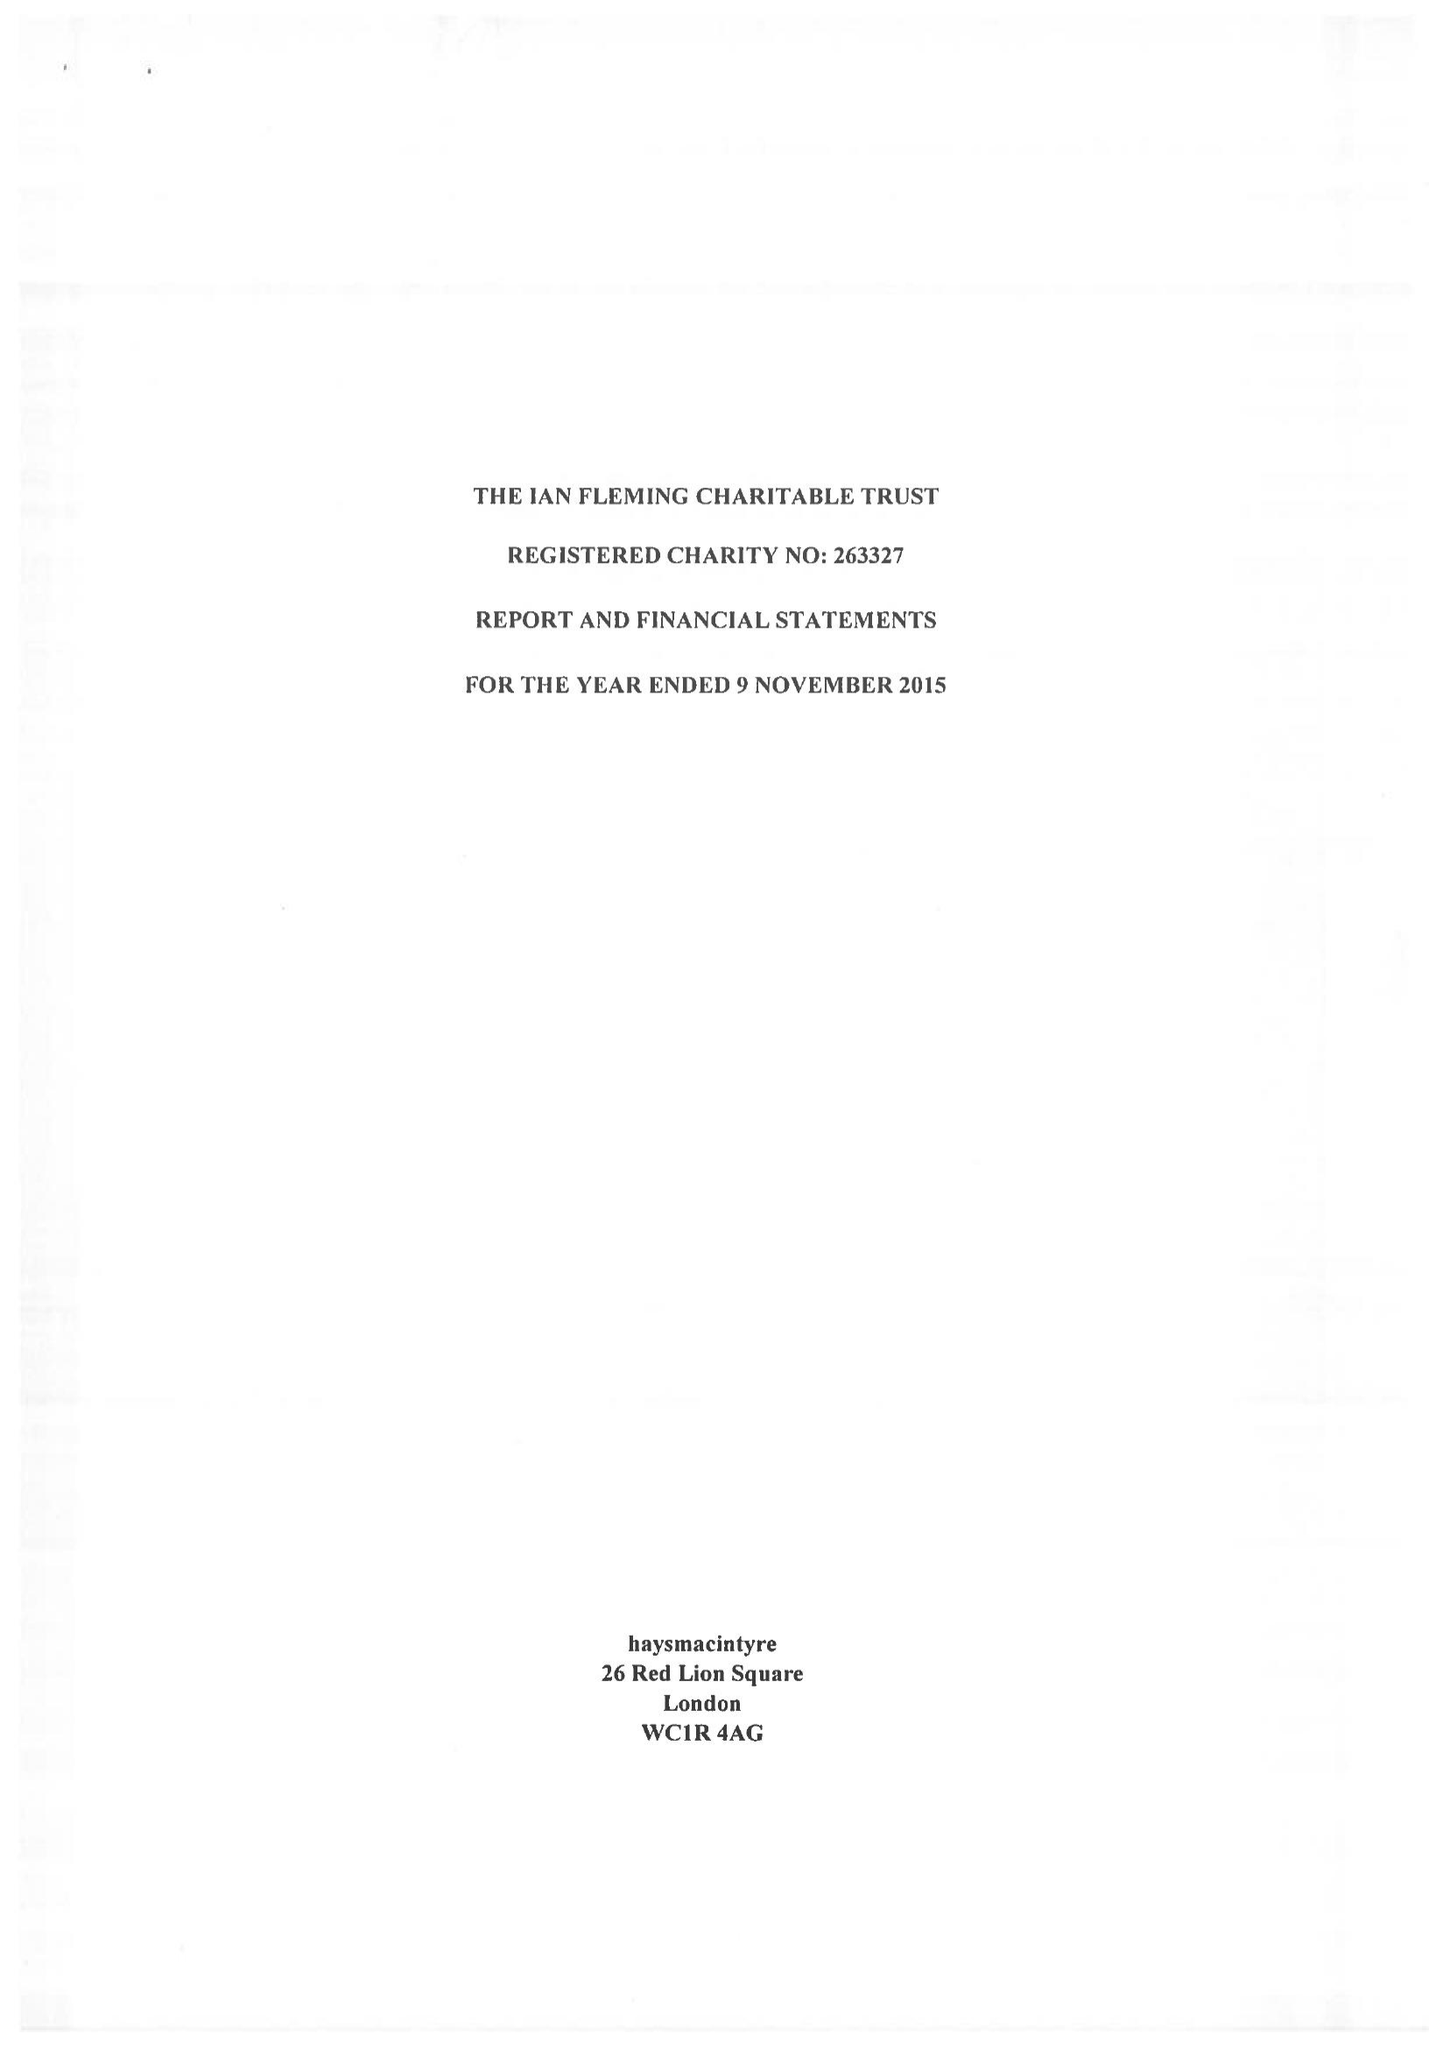What is the value for the charity_number?
Answer the question using a single word or phrase. 263327 